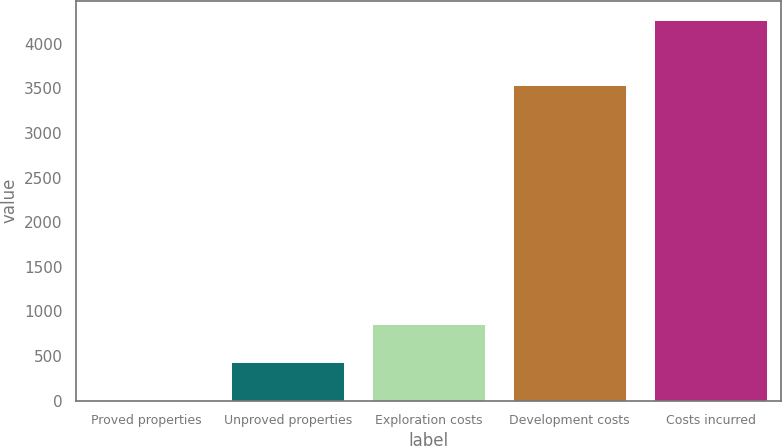Convert chart. <chart><loc_0><loc_0><loc_500><loc_500><bar_chart><fcel>Proved properties<fcel>Unproved properties<fcel>Exploration costs<fcel>Development costs<fcel>Costs incurred<nl><fcel>3<fcel>429.7<fcel>856.4<fcel>3542<fcel>4270<nl></chart> 